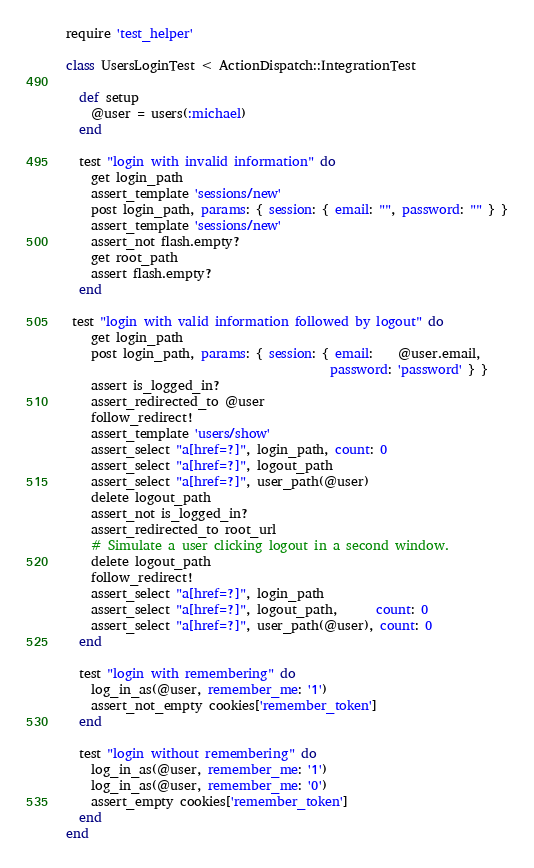<code> <loc_0><loc_0><loc_500><loc_500><_Ruby_>require 'test_helper'

class UsersLoginTest < ActionDispatch::IntegrationTest

  def setup
    @user = users(:michael)
  end

  test "login with invalid information" do
    get login_path
    assert_template 'sessions/new'
    post login_path, params: { session: { email: "", password: "" } }
    assert_template 'sessions/new'
    assert_not flash.empty?
    get root_path
    assert flash.empty?
  end

 test "login with valid information followed by logout" do
    get login_path
    post login_path, params: { session: { email:    @user.email,
                                          password: 'password' } }
    assert is_logged_in?
    assert_redirected_to @user
    follow_redirect!
    assert_template 'users/show'
    assert_select "a[href=?]", login_path, count: 0
    assert_select "a[href=?]", logout_path
    assert_select "a[href=?]", user_path(@user)
    delete logout_path
    assert_not is_logged_in?
    assert_redirected_to root_url
    # Simulate a user clicking logout in a second window.
    delete logout_path
    follow_redirect!
    assert_select "a[href=?]", login_path
    assert_select "a[href=?]", logout_path,      count: 0
    assert_select "a[href=?]", user_path(@user), count: 0
  end

  test "login with remembering" do
    log_in_as(@user, remember_me: '1')
    assert_not_empty cookies['remember_token']
  end

  test "login without remembering" do
    log_in_as(@user, remember_me: '1')
    log_in_as(@user, remember_me: '0')
    assert_empty cookies['remember_token']
  end
end

</code> 